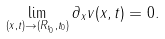<formula> <loc_0><loc_0><loc_500><loc_500>\lim _ { ( x , t ) \to ( R _ { t _ { 0 } } , t _ { 0 } ) } \partial _ { x } v ( x , t ) = 0 .</formula> 